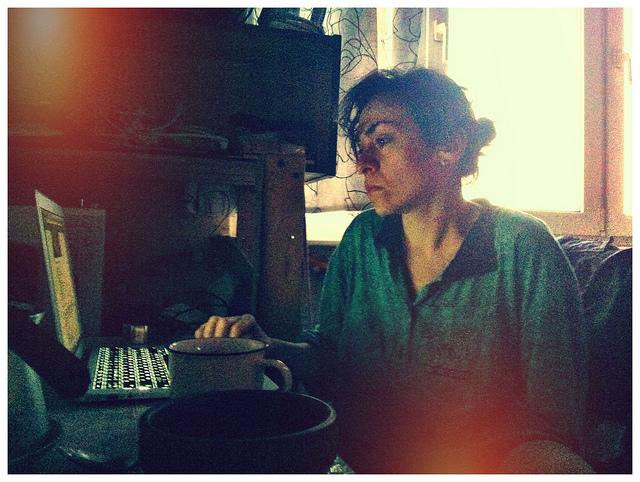What is the woman looking at?
Give a very brief answer. Laptop. Does the woman look stressed?
Short answer required. Yes. How many computers are present?
Quick response, please. 1. 